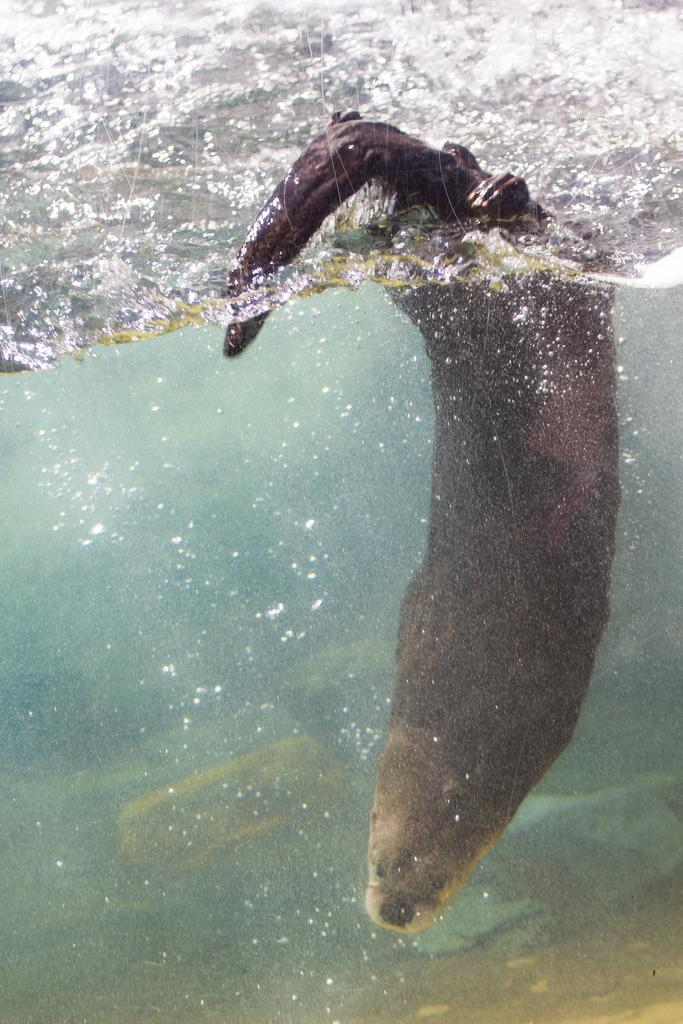What type of animal is in the image? There is a sea lion in the image. Where is the sea lion located? The sea lion is in the water. What type of string is being used to control the fire in the image? There is no string or fire present in the image; it features a sea lion in the water. 